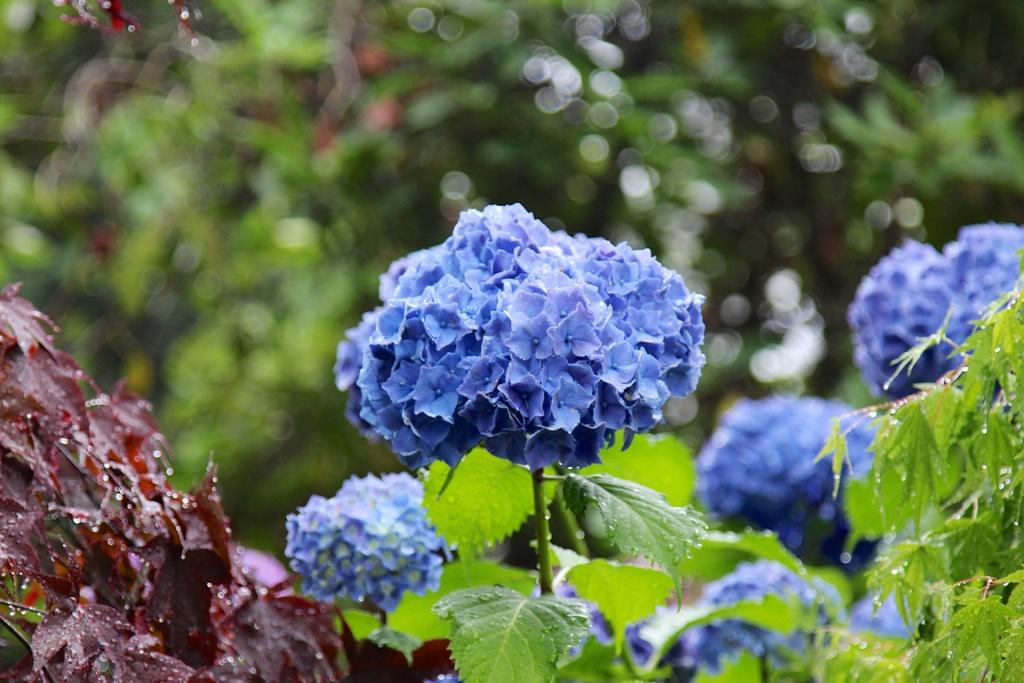What type of plants can be seen in the image? There are plants with flowers in the image. Can you describe the background of the image? The background of the image is blurred. What type of rock is being used as a vessel for the voyage in the image? There is no rock or voyage present in the image; it features plants with flowers and a blurred background. 